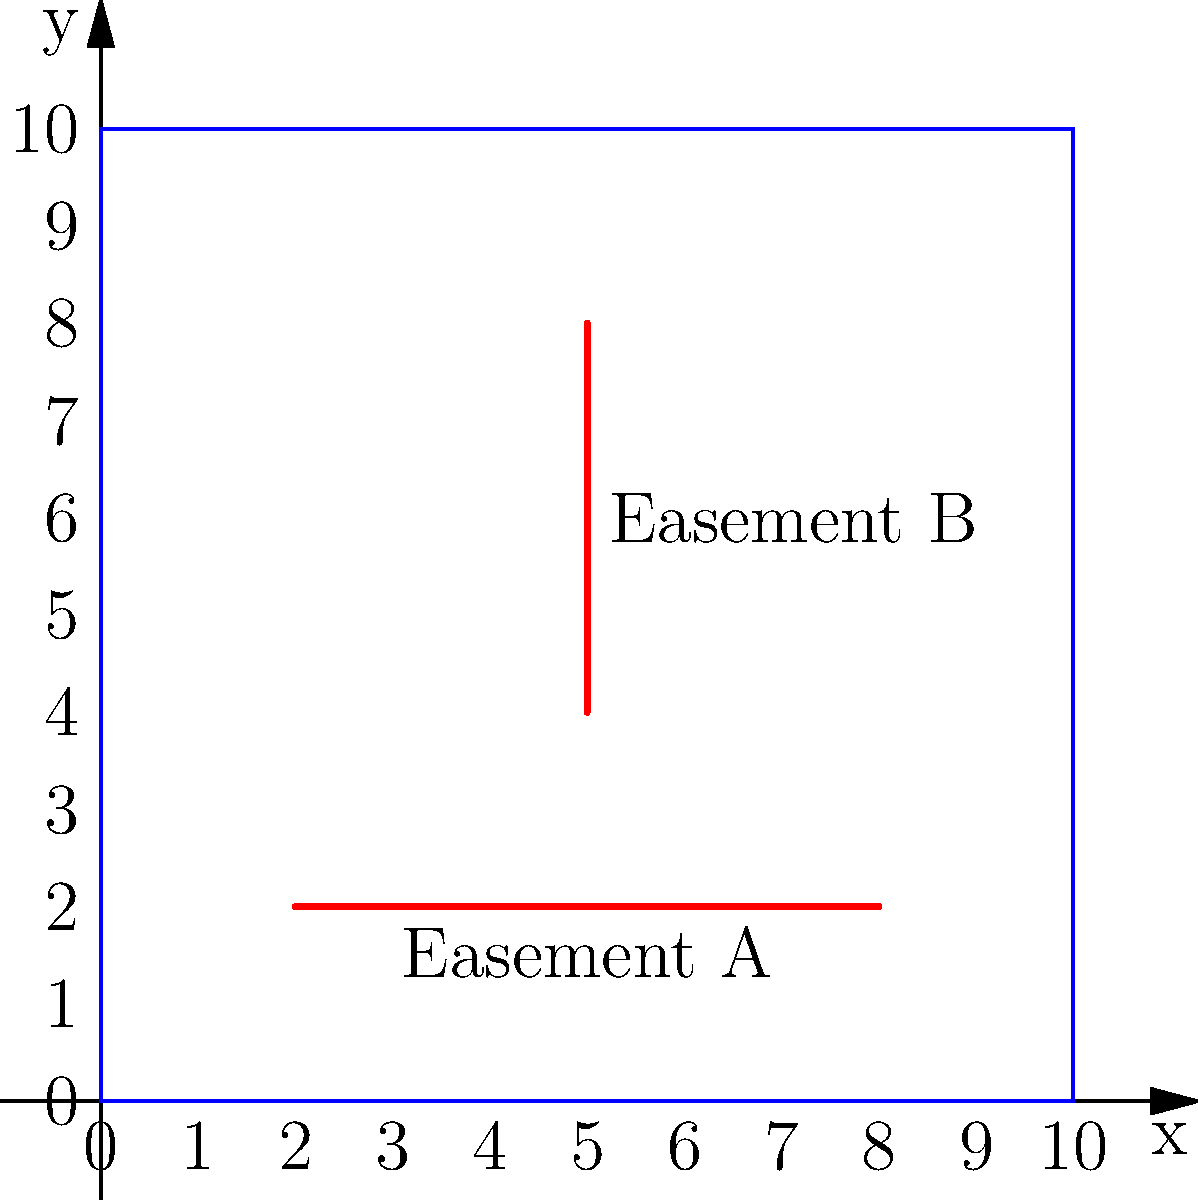Given the property map above with a coordinate system where each unit represents 10 feet, calculate the total length of easements on the property. Easement A runs horizontally from (2,2) to (8,2), and Easement B runs vertically from (5,4) to (5,8). To calculate the total length of easements, we need to determine the length of each easement and then sum them up. Let's approach this step-by-step:

1. Calculate the length of Easement A:
   - Easement A runs from (2,2) to (8,2)
   - The length is the difference in x-coordinates: $8 - 2 = 6$ units
   - Each unit represents 10 feet, so the actual length is $6 \times 10 = 60$ feet

2. Calculate the length of Easement B:
   - Easement B runs from (5,4) to (5,8)
   - The length is the difference in y-coordinates: $8 - 4 = 4$ units
   - Each unit represents 10 feet, so the actual length is $4 \times 10 = 40$ feet

3. Sum up the total length of easements:
   - Total length = Length of Easement A + Length of Easement B
   - Total length = $60$ feet + $40$ feet = $100$ feet

Therefore, the total length of easements on the property is 100 feet.
Answer: 100 feet 